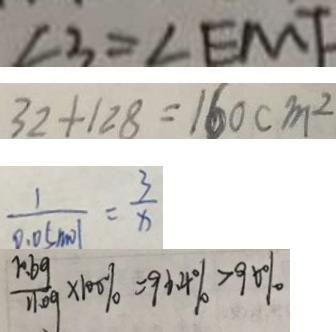Convert formula to latex. <formula><loc_0><loc_0><loc_500><loc_500>\angle 3 = \angle E M F 
 3 2 + 1 2 8 = 1 6 0 c m ^ { 2 } 
 \frac { 1 } { 9 . 0 5 m o l } = \frac { 3 } { x } 
 \frac { 1 0 . 6 g } { 1 1 . 0 g } \times 1 0 0 \% = 9 6 . 4 \% > 9 0 \%</formula> 